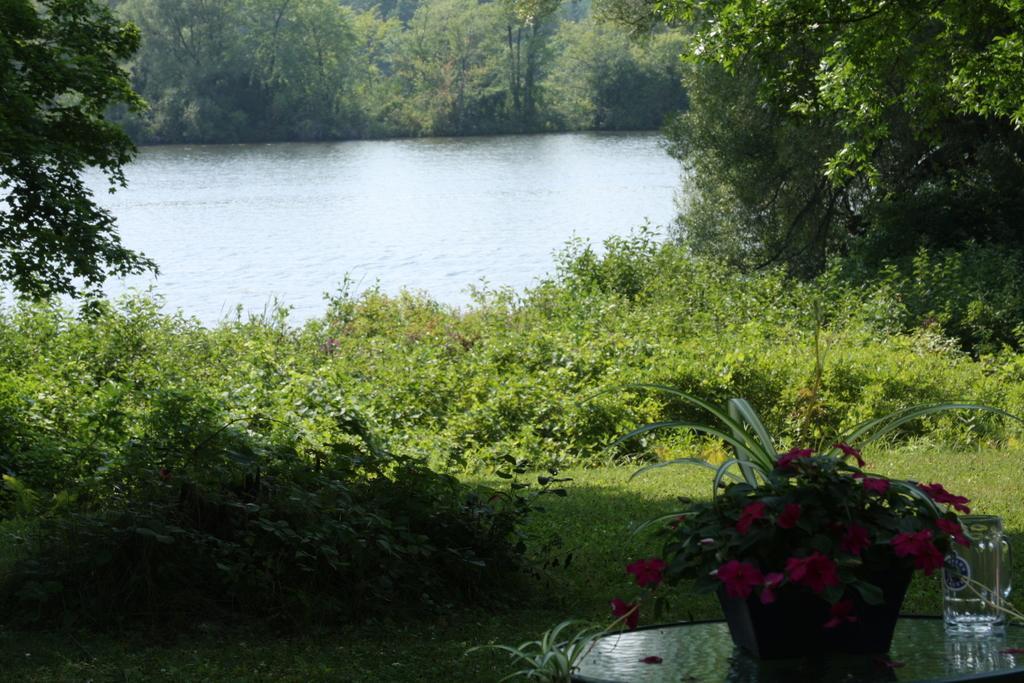In one or two sentences, can you explain what this image depicts? In the right bottom of the picture, we see a table on which glass jar and a flower pot are placed. At the bottom of the picture, we see the grass and herbs. On either side of the picture, we see trees. In the middle of the picture, we see water and this water might be in the pond. There are trees in the background. 